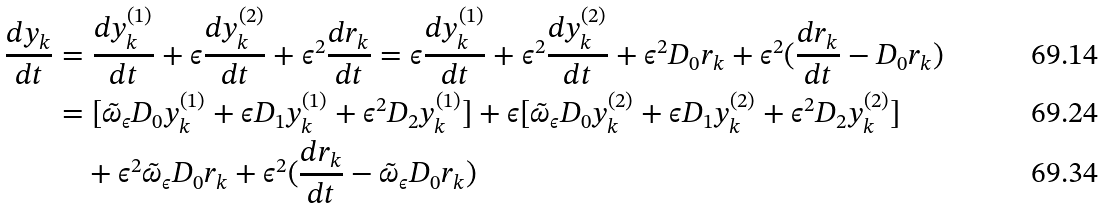Convert formula to latex. <formula><loc_0><loc_0><loc_500><loc_500>\frac { d y _ { k } } { d t } & = \frac { d y _ { k } ^ { ( 1 ) } } { d t } + \epsilon \frac { d y _ { k } ^ { ( 2 ) } } { d t } + \epsilon ^ { 2 } \frac { d r _ { k } } { d t } = \epsilon \frac { d y _ { k } ^ { ( 1 ) } } { d t } + \epsilon ^ { 2 } \frac { d y _ { k } ^ { ( 2 ) } } { d t } + \epsilon ^ { 2 } D _ { 0 } r _ { k } + \epsilon ^ { 2 } ( \frac { d r _ { k } } { d t } - D _ { 0 } r _ { k } ) \\ & = [ \tilde { \omega } _ { \epsilon } D _ { 0 } y _ { k } ^ { ( 1 ) } + \epsilon D _ { 1 } y _ { k } ^ { ( 1 ) } + \epsilon ^ { 2 } D _ { 2 } y _ { k } ^ { ( 1 ) } ] + \epsilon [ \tilde { \omega } _ { \epsilon } D _ { 0 } y _ { k } ^ { ( 2 ) } + \epsilon D _ { 1 } y _ { k } ^ { ( 2 ) } + \epsilon ^ { 2 } D _ { 2 } y _ { k } ^ { ( 2 ) } ] \\ & \quad + \epsilon ^ { 2 } \tilde { \omega } _ { \epsilon } D _ { 0 } r _ { k } + \epsilon ^ { 2 } ( \frac { d r _ { k } } { d t } - \tilde { \omega } _ { \epsilon } D _ { 0 } r _ { k } )</formula> 